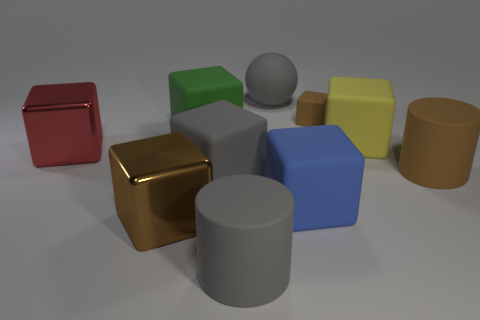Is there another large block made of the same material as the red cube?
Make the answer very short. Yes. How many large gray things are both to the right of the gray rubber block and in front of the large rubber ball?
Offer a very short reply. 1. There is a brown block that is on the left side of the big green rubber thing; what is it made of?
Ensure brevity in your answer.  Metal. The gray ball that is made of the same material as the blue cube is what size?
Offer a terse response. Large. There is a gray sphere; are there any brown matte cylinders in front of it?
Your answer should be very brief. Yes. There is a red object that is the same shape as the brown metallic thing; what is its size?
Your answer should be compact. Large. Is the color of the tiny rubber cube the same as the cylinder to the right of the big gray sphere?
Offer a very short reply. Yes. Are there fewer large brown metallic objects than brown cubes?
Make the answer very short. Yes. What number of other objects are there of the same color as the big ball?
Your answer should be compact. 2. What number of small purple rubber objects are there?
Provide a succinct answer. 0. 